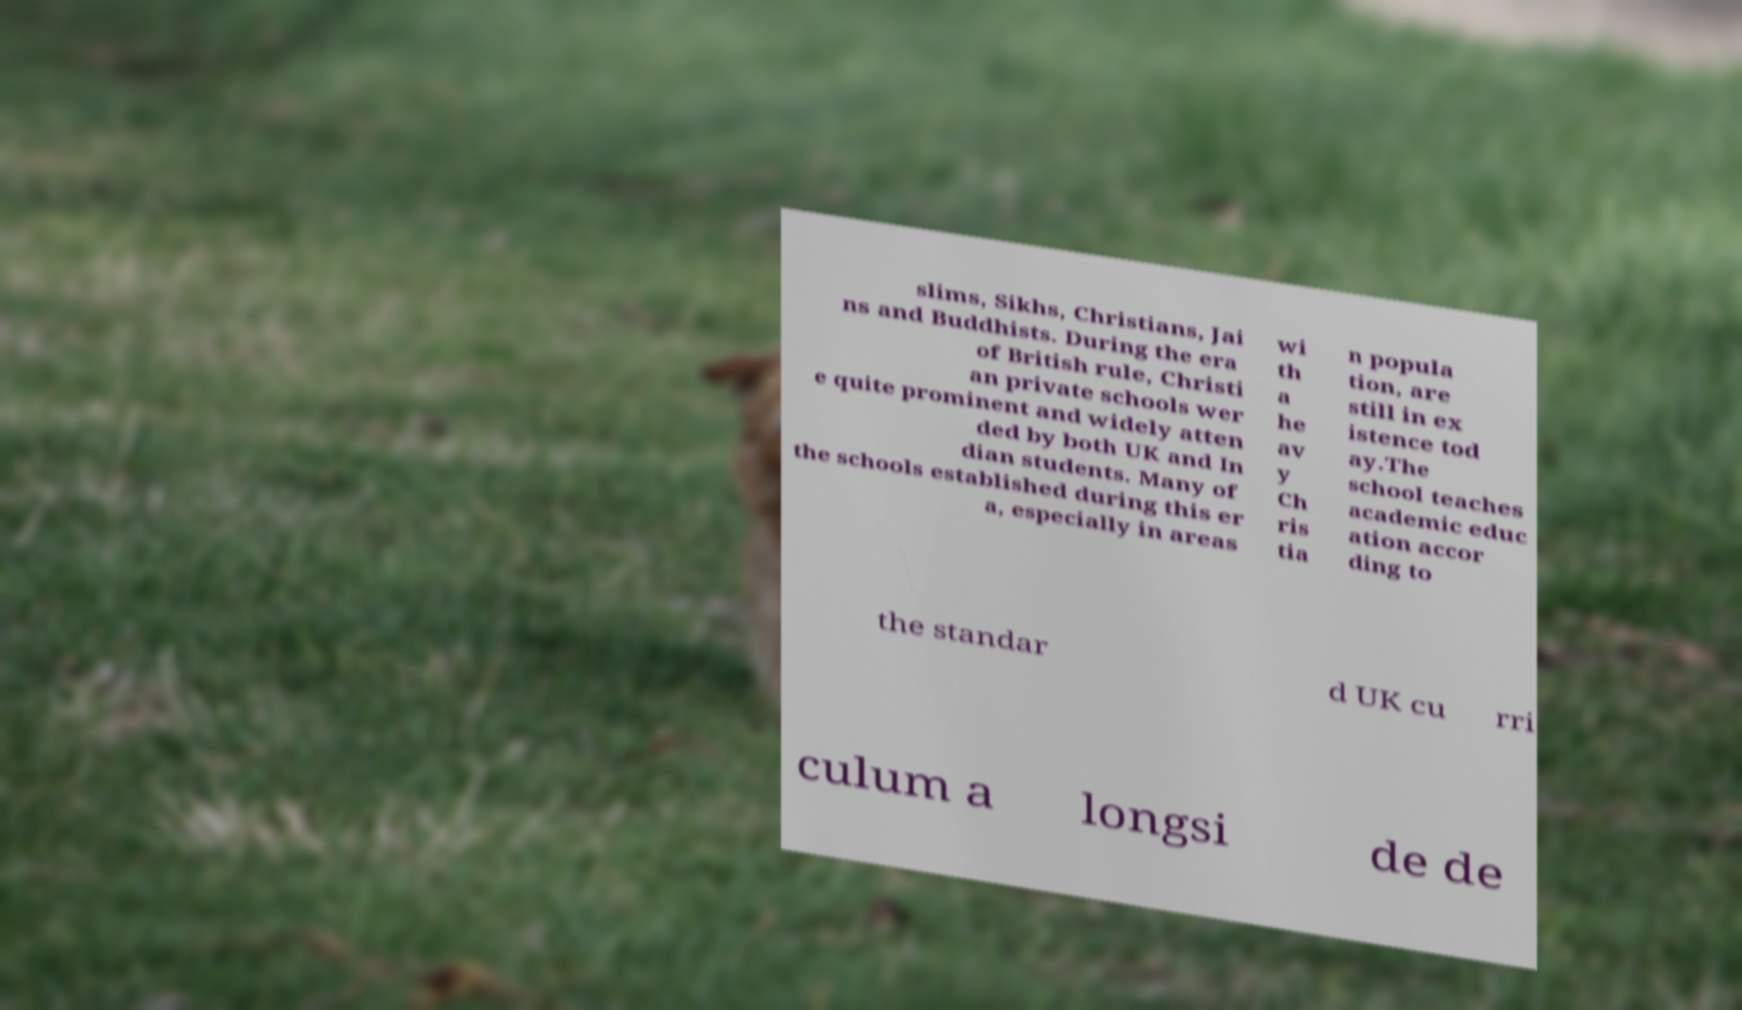Could you assist in decoding the text presented in this image and type it out clearly? slims, Sikhs, Christians, Jai ns and Buddhists. During the era of British rule, Christi an private schools wer e quite prominent and widely atten ded by both UK and In dian students. Many of the schools established during this er a, especially in areas wi th a he av y Ch ris tia n popula tion, are still in ex istence tod ay.The school teaches academic educ ation accor ding to the standar d UK cu rri culum a longsi de de 